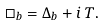Convert formula to latex. <formula><loc_0><loc_0><loc_500><loc_500>\square _ { b } = \Delta _ { b } + i \, T .</formula> 